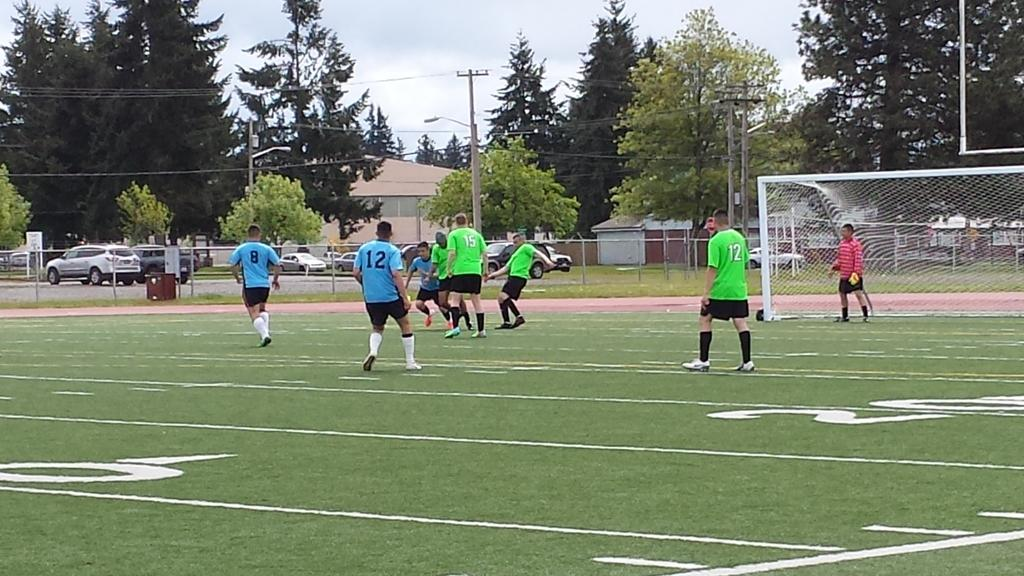<image>
Give a short and clear explanation of the subsequent image. A group of soccer player are onfield, number 8 running to the left. 